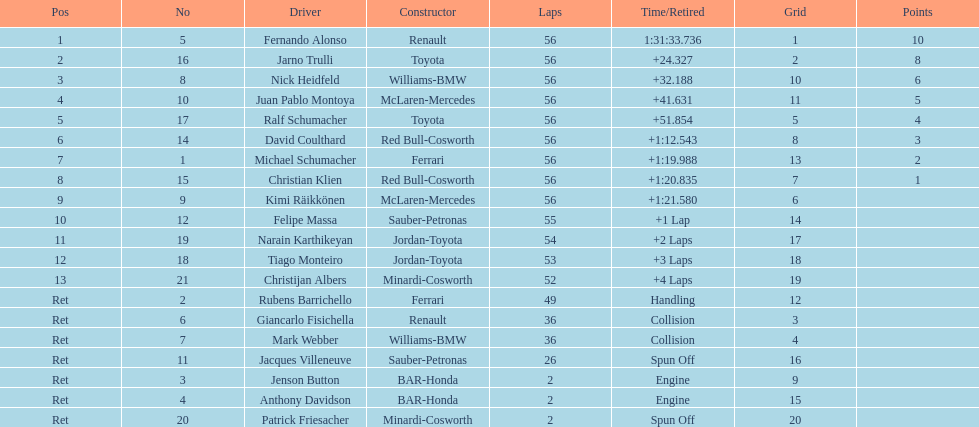How long did it take fernando alonso to finish the race? 1:31:33.736. 